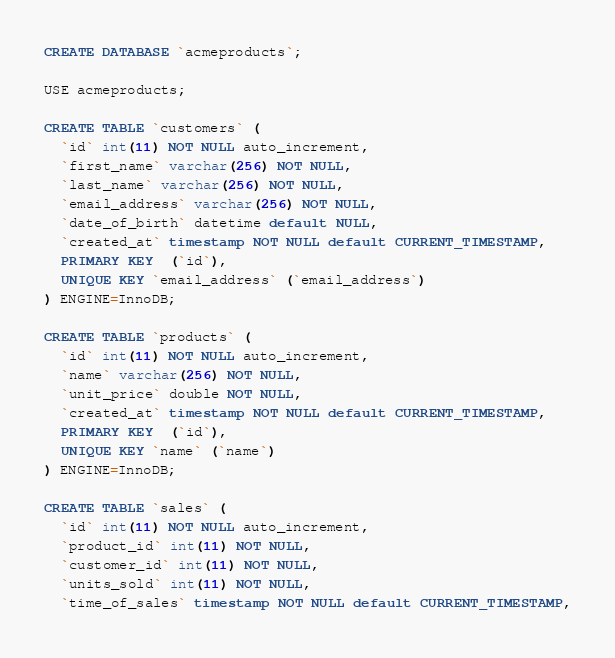Convert code to text. <code><loc_0><loc_0><loc_500><loc_500><_SQL_>CREATE DATABASE `acmeproducts`;

USE acmeproducts;

CREATE TABLE `customers` (
  `id` int(11) NOT NULL auto_increment,
  `first_name` varchar(256) NOT NULL,
  `last_name` varchar(256) NOT NULL,
  `email_address` varchar(256) NOT NULL,
  `date_of_birth` datetime default NULL,
  `created_at` timestamp NOT NULL default CURRENT_TIMESTAMP,
  PRIMARY KEY  (`id`),
  UNIQUE KEY `email_address` (`email_address`)
) ENGINE=InnoDB;

CREATE TABLE `products` (
  `id` int(11) NOT NULL auto_increment,
  `name` varchar(256) NOT NULL,
  `unit_price` double NOT NULL,
  `created_at` timestamp NOT NULL default CURRENT_TIMESTAMP,
  PRIMARY KEY  (`id`),
  UNIQUE KEY `name` (`name`)
) ENGINE=InnoDB;

CREATE TABLE `sales` (
  `id` int(11) NOT NULL auto_increment,
  `product_id` int(11) NOT NULL,
  `customer_id` int(11) NOT NULL,
  `units_sold` int(11) NOT NULL,
  `time_of_sales` timestamp NOT NULL default CURRENT_TIMESTAMP,</code> 